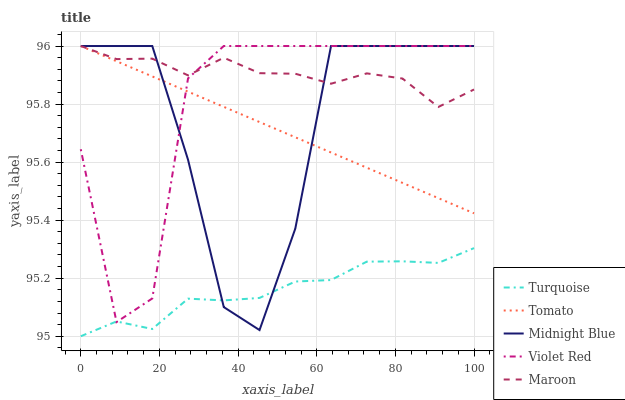Does Turquoise have the minimum area under the curve?
Answer yes or no. Yes. Does Maroon have the maximum area under the curve?
Answer yes or no. Yes. Does Violet Red have the minimum area under the curve?
Answer yes or no. No. Does Violet Red have the maximum area under the curve?
Answer yes or no. No. Is Tomato the smoothest?
Answer yes or no. Yes. Is Midnight Blue the roughest?
Answer yes or no. Yes. Is Violet Red the smoothest?
Answer yes or no. No. Is Violet Red the roughest?
Answer yes or no. No. Does Turquoise have the lowest value?
Answer yes or no. Yes. Does Violet Red have the lowest value?
Answer yes or no. No. Does Maroon have the highest value?
Answer yes or no. Yes. Does Turquoise have the highest value?
Answer yes or no. No. Is Turquoise less than Tomato?
Answer yes or no. Yes. Is Maroon greater than Turquoise?
Answer yes or no. Yes. Does Violet Red intersect Tomato?
Answer yes or no. Yes. Is Violet Red less than Tomato?
Answer yes or no. No. Is Violet Red greater than Tomato?
Answer yes or no. No. Does Turquoise intersect Tomato?
Answer yes or no. No. 